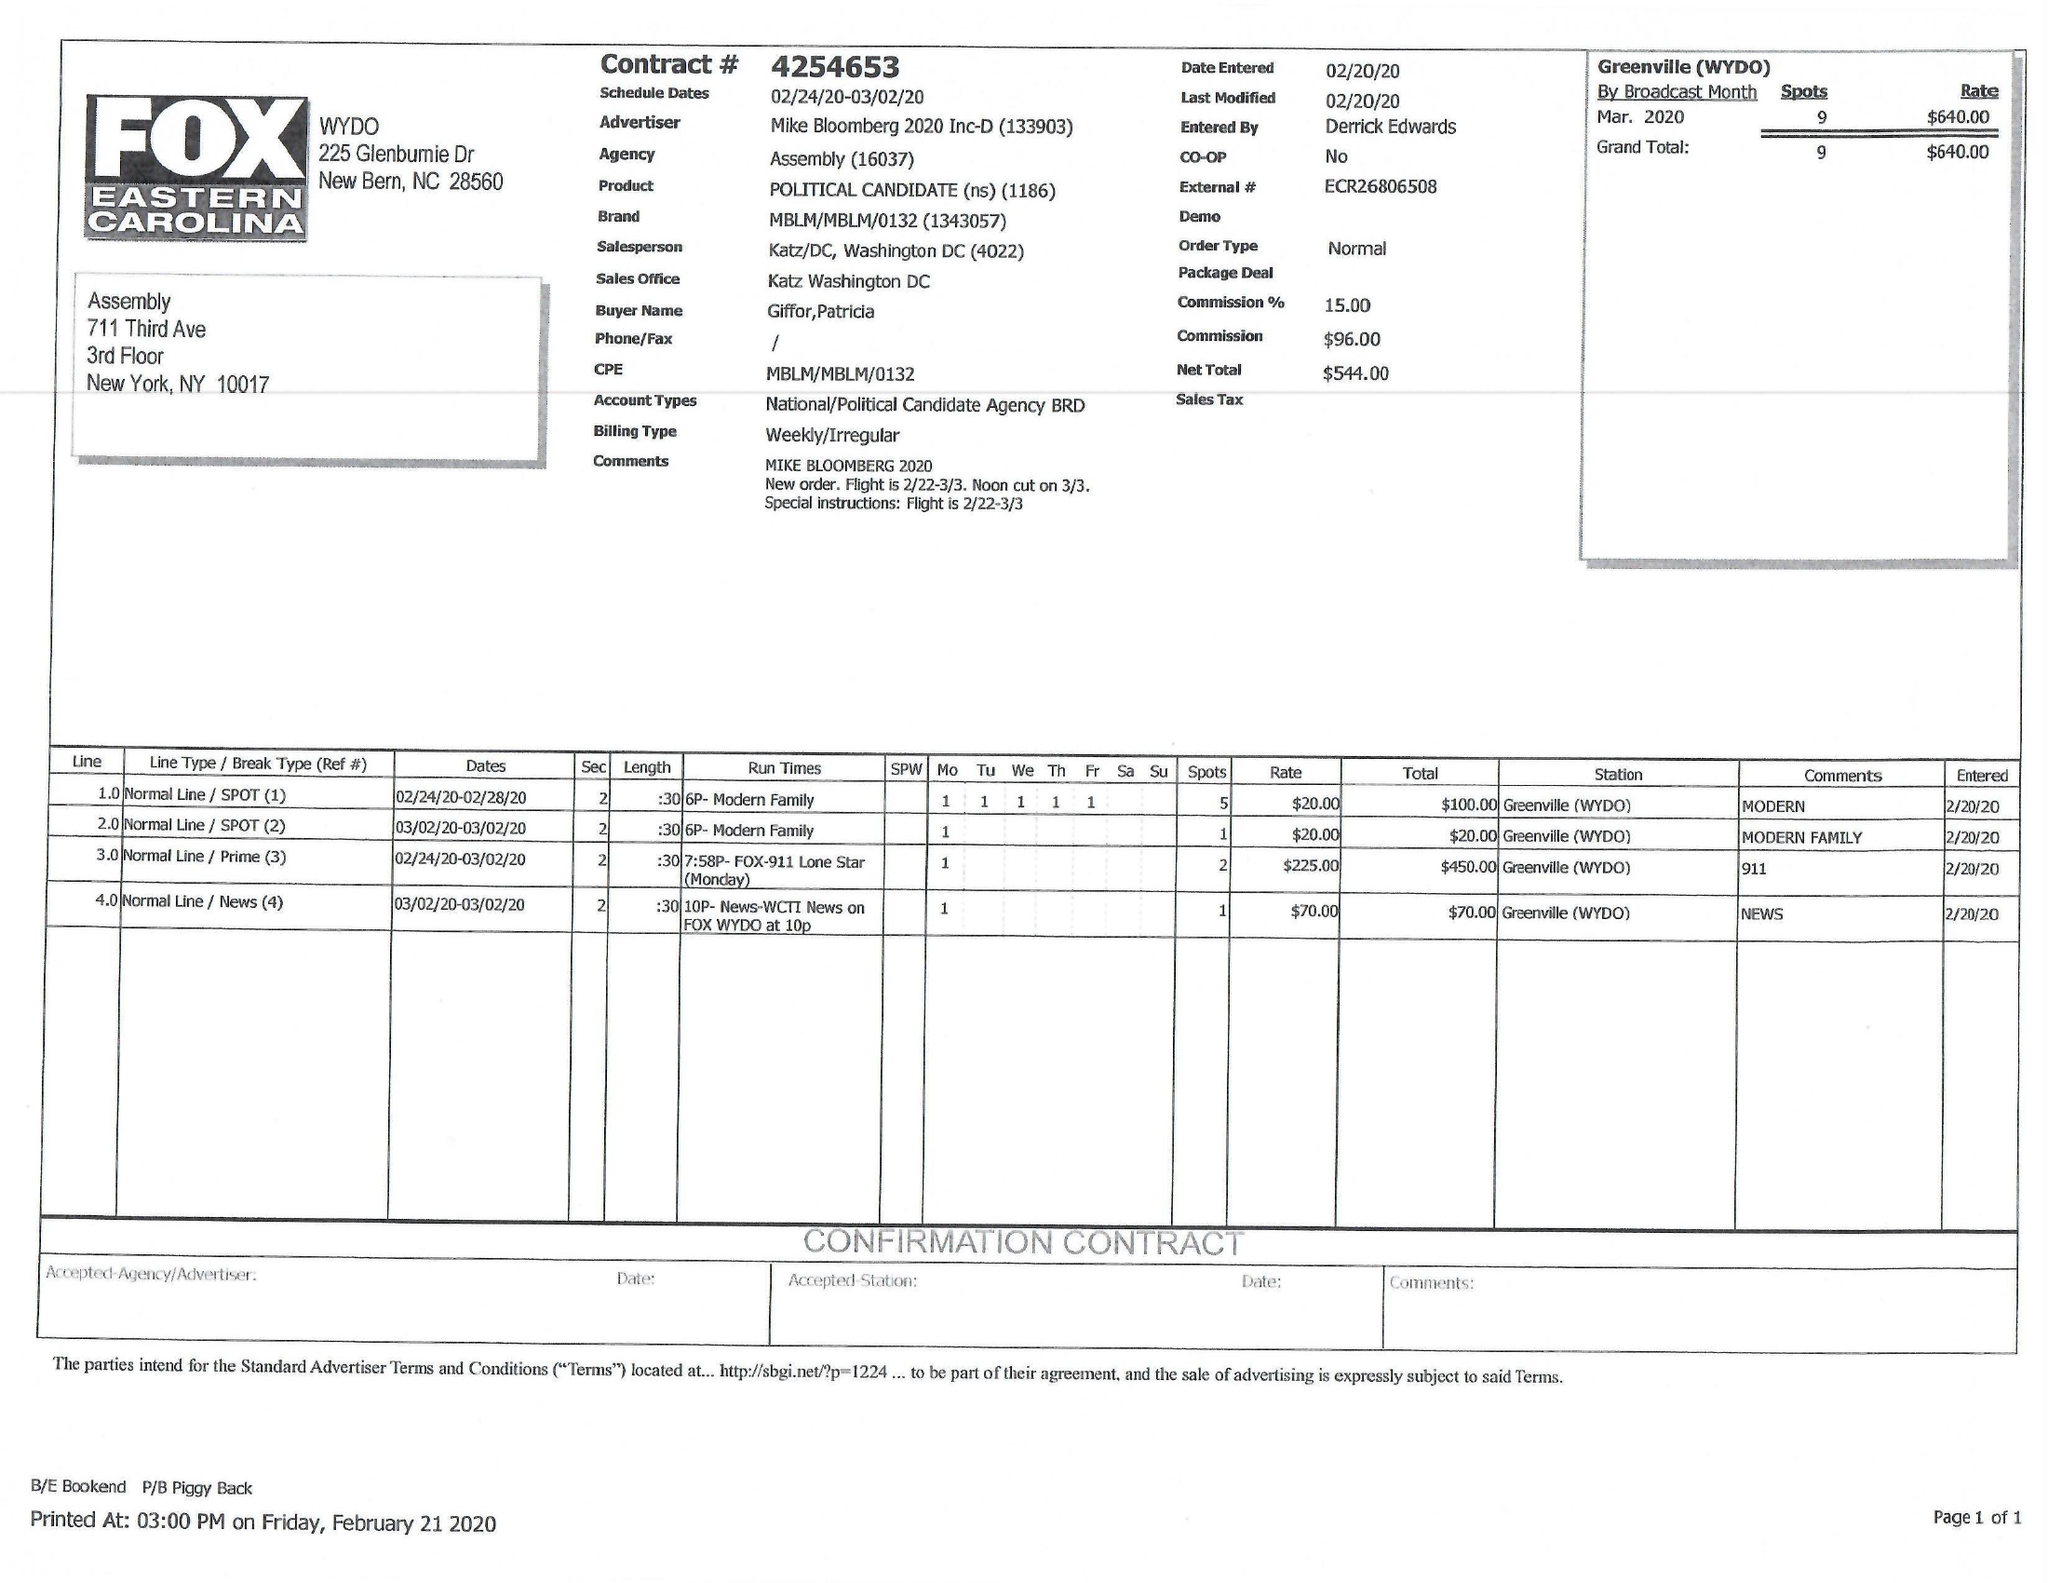What is the value for the gross_amount?
Answer the question using a single word or phrase. 640.00 